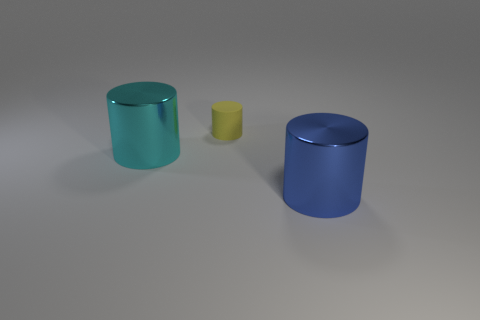There is a thing that is behind the big thing that is to the left of the big blue metal object; what shape is it? The object positioned behind the larger item, to the left of the prominent blue cylinder, is also a cylinder, though smaller in size and yellow in color. 